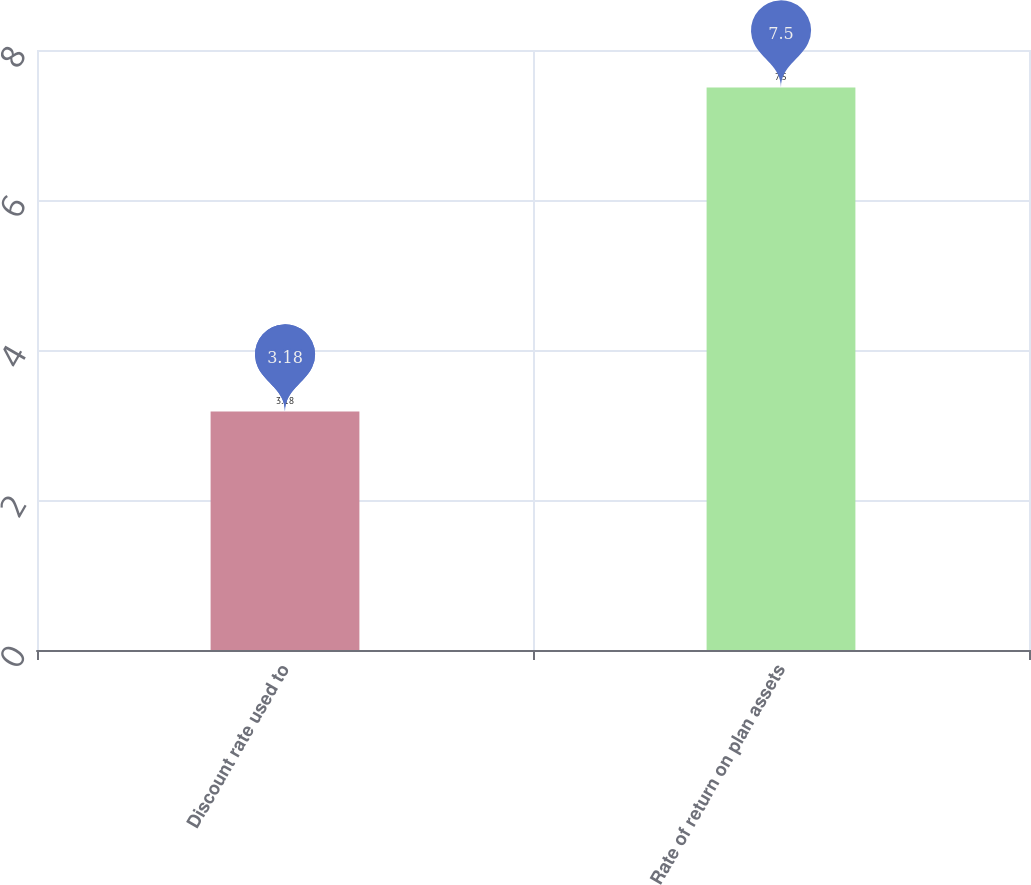Convert chart to OTSL. <chart><loc_0><loc_0><loc_500><loc_500><bar_chart><fcel>Discount rate used to<fcel>Rate of return on plan assets<nl><fcel>3.18<fcel>7.5<nl></chart> 